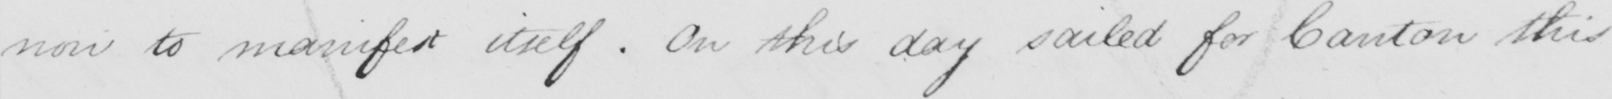What does this handwritten line say? now to manifest itself . On this day sailed for Canton this 